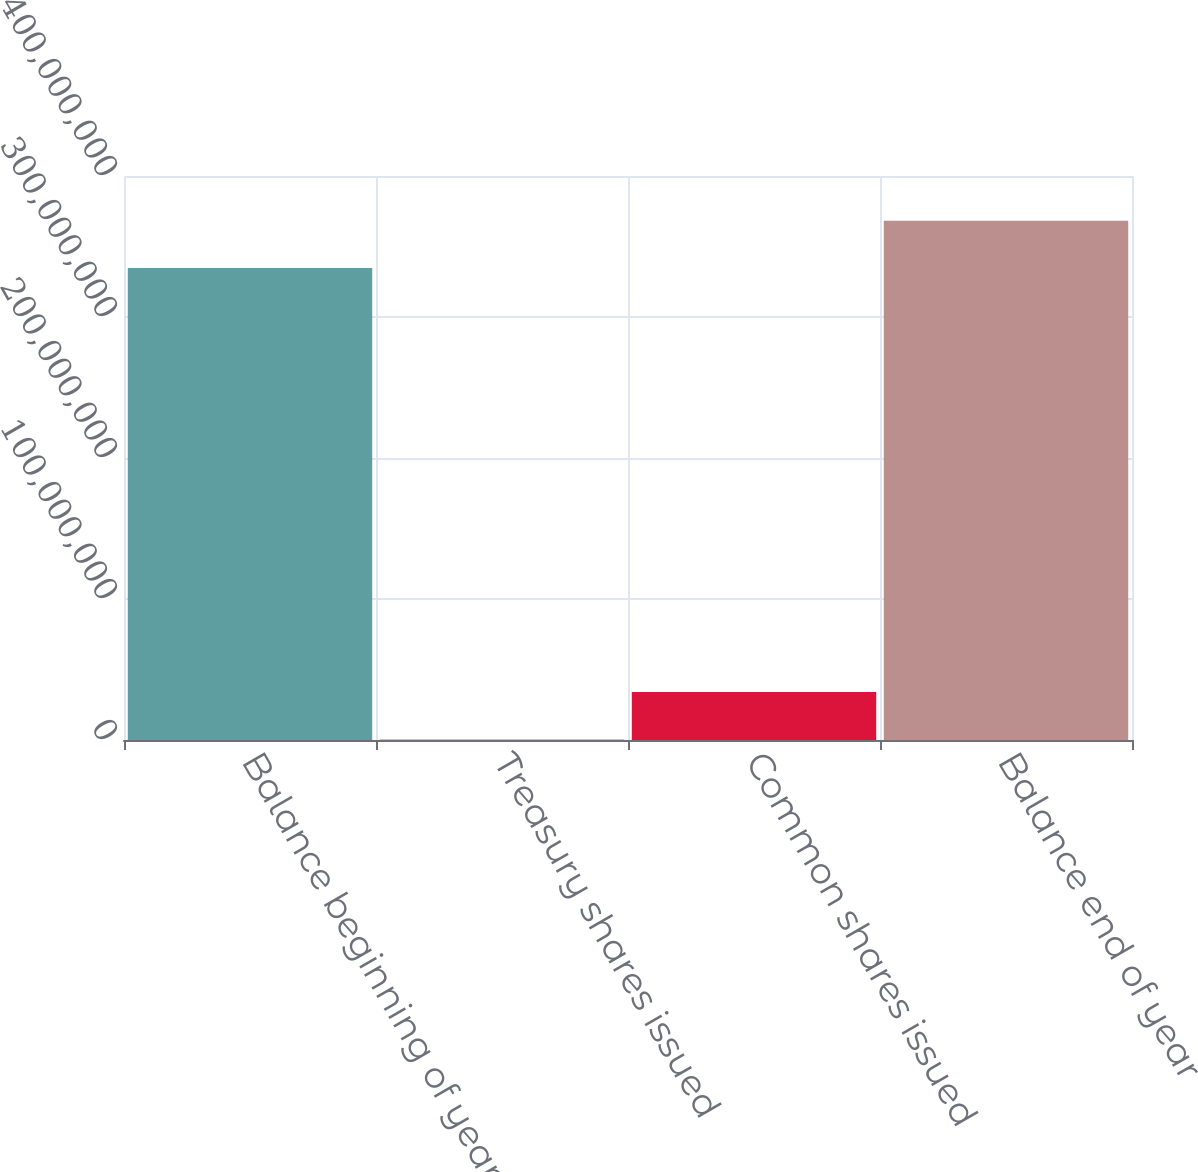<chart> <loc_0><loc_0><loc_500><loc_500><bar_chart><fcel>Balance beginning of year<fcel>Treasury shares issued<fcel>Common shares issued<fcel>Balance end of year<nl><fcel>3.3471e+08<fcel>404232<fcel>3.40075e+07<fcel>3.68313e+08<nl></chart> 